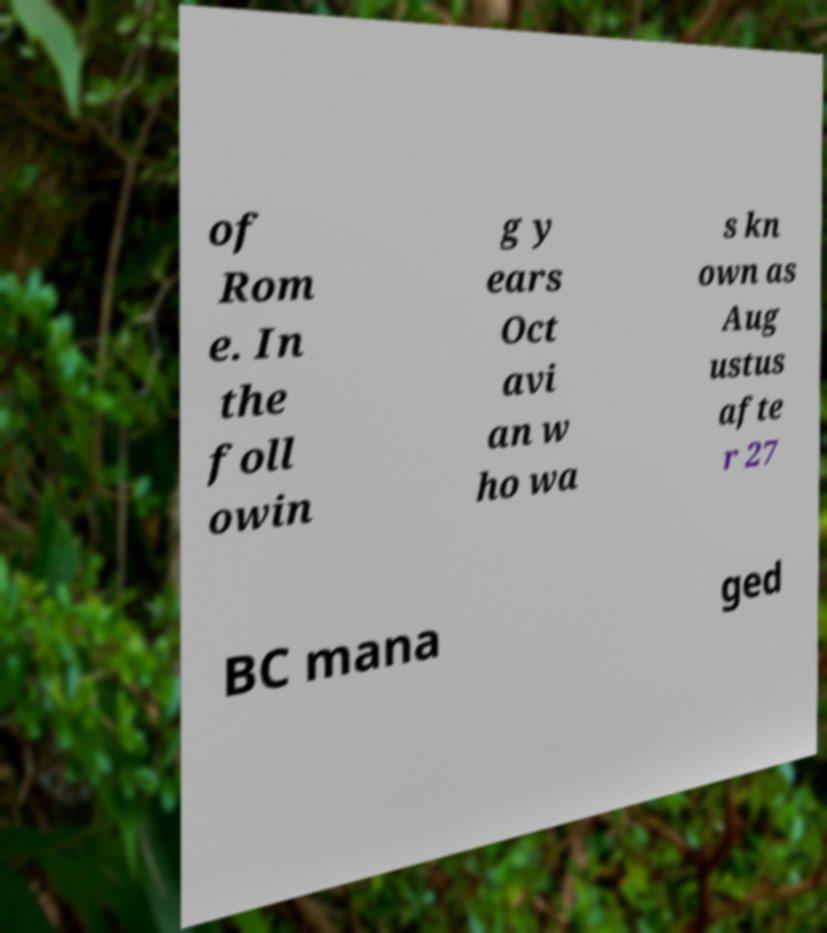I need the written content from this picture converted into text. Can you do that? of Rom e. In the foll owin g y ears Oct avi an w ho wa s kn own as Aug ustus afte r 27 BC mana ged 